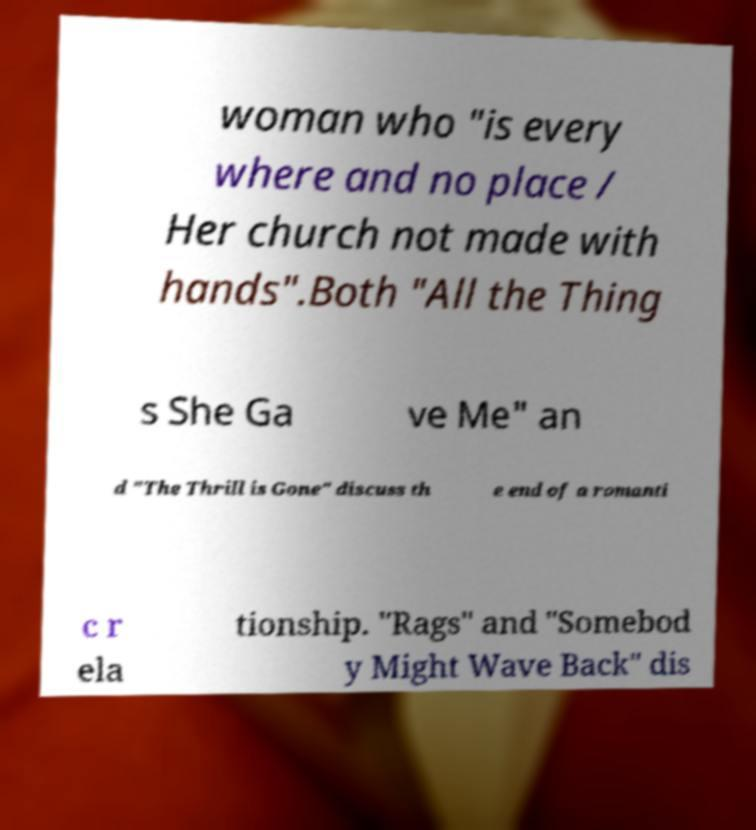Could you extract and type out the text from this image? woman who "is every where and no place / Her church not made with hands".Both "All the Thing s She Ga ve Me" an d "The Thrill is Gone" discuss th e end of a romanti c r ela tionship. "Rags" and "Somebod y Might Wave Back" dis 